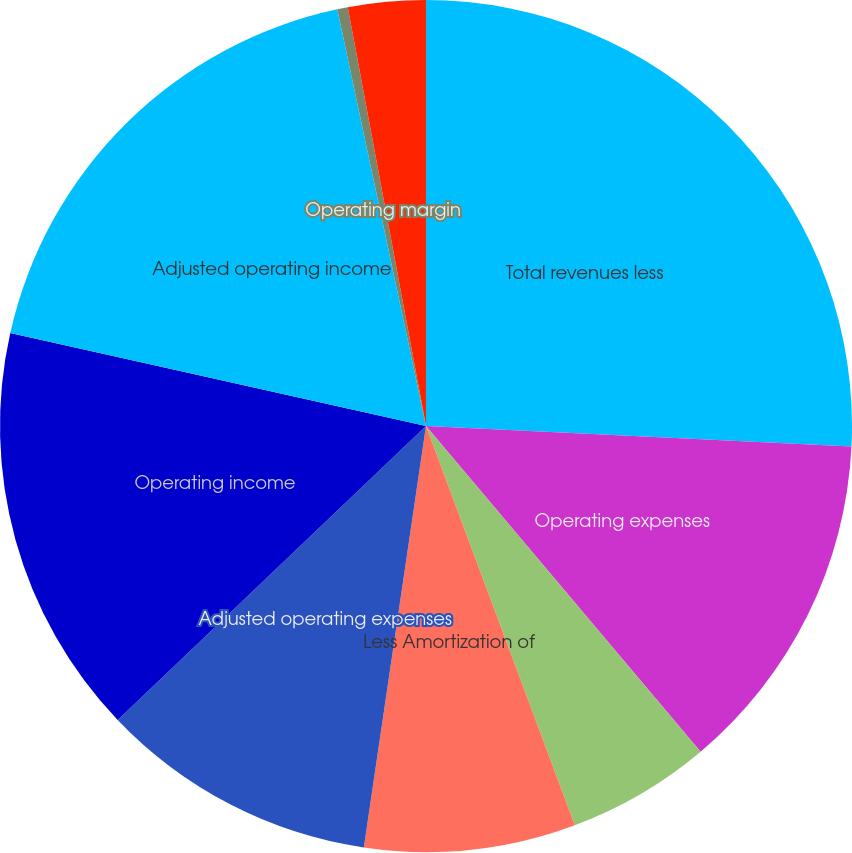<chart> <loc_0><loc_0><loc_500><loc_500><pie_chart><fcel>Total revenues less<fcel>Operating expenses<fcel>Less NYSE and Interactive Data<fcel>Less Amortization of<fcel>Adjusted operating expenses<fcel>Operating income<fcel>Adjusted operating income<fcel>Operating margin<fcel>Adjusted operating margin<nl><fcel>25.77%<fcel>13.08%<fcel>5.47%<fcel>8.01%<fcel>10.55%<fcel>15.62%<fcel>18.16%<fcel>0.4%<fcel>2.94%<nl></chart> 